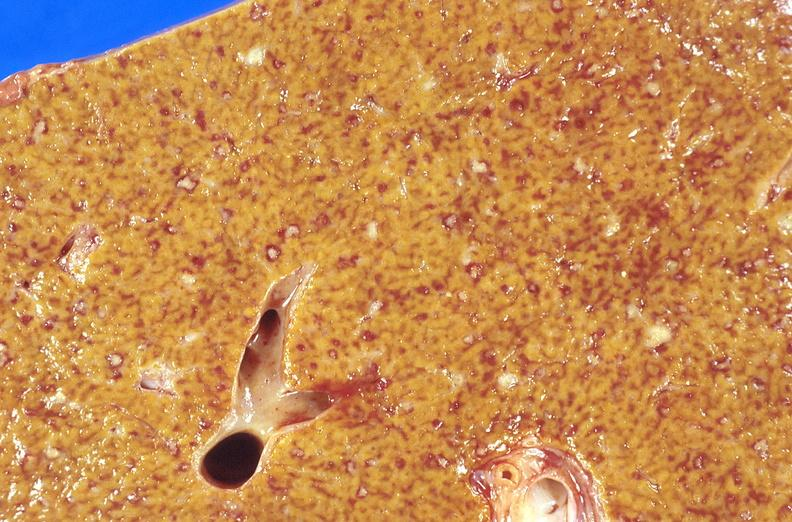does nodule show liver, miliary tuberculosis?
Answer the question using a single word or phrase. No 